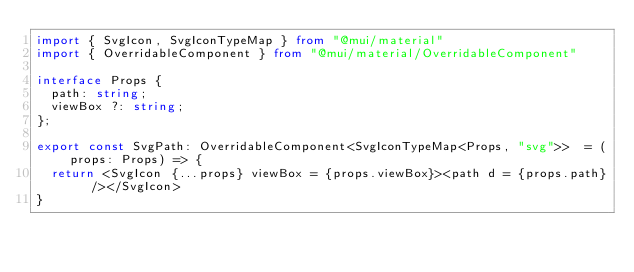Convert code to text. <code><loc_0><loc_0><loc_500><loc_500><_TypeScript_>import { SvgIcon, SvgIconTypeMap } from "@mui/material"
import { OverridableComponent } from "@mui/material/OverridableComponent"

interface Props {
  path: string;
  viewBox ?: string;
};

export const SvgPath: OverridableComponent<SvgIconTypeMap<Props, "svg">>  = (props: Props) => {
  return <SvgIcon {...props} viewBox = {props.viewBox}><path d = {props.path} /></SvgIcon>
}
</code> 